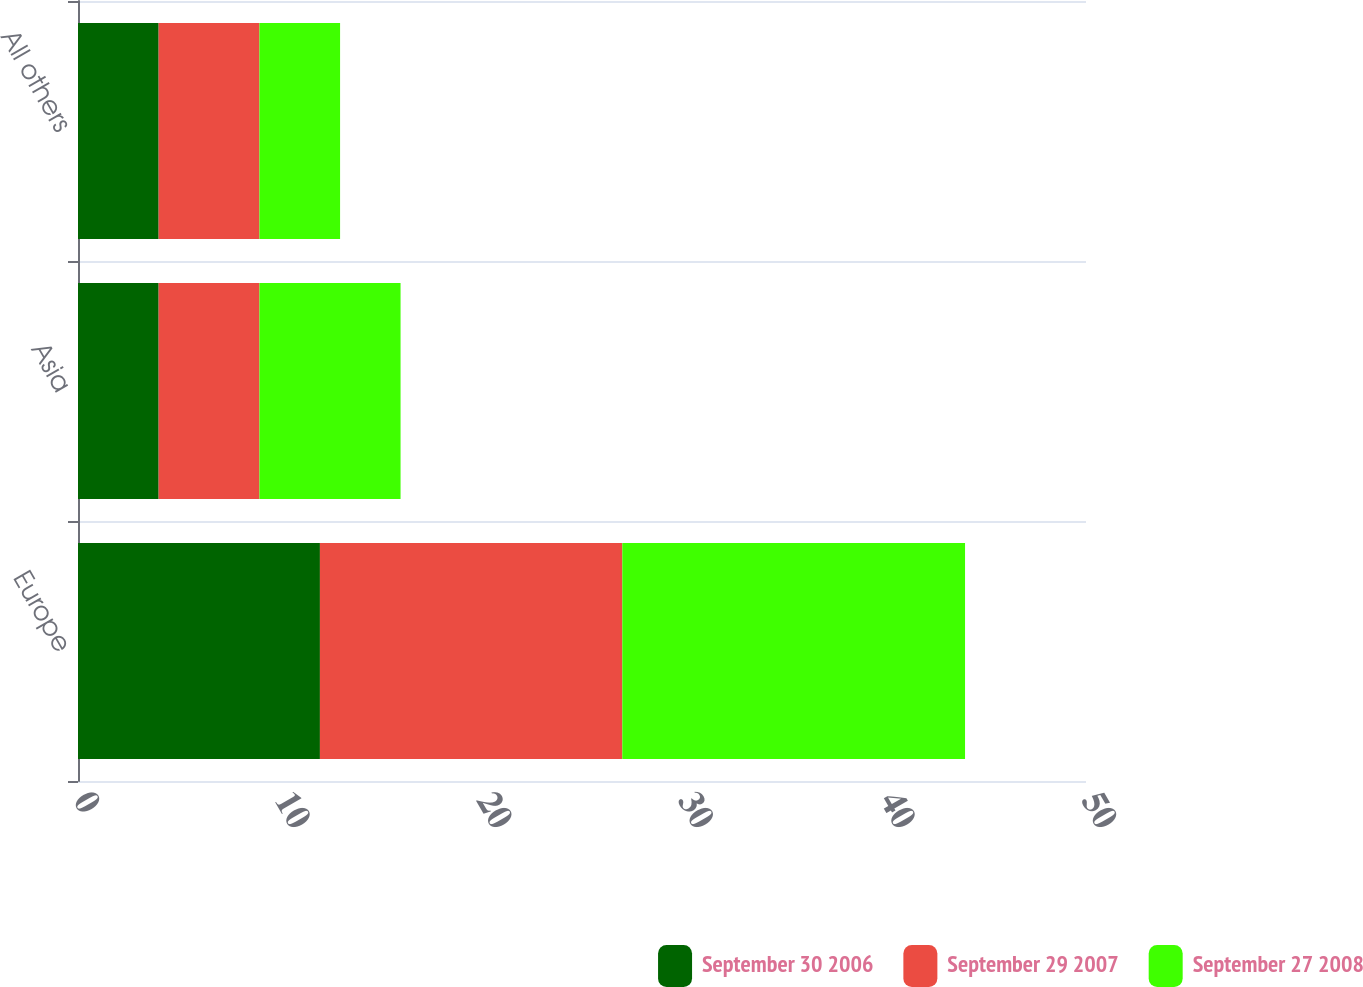Convert chart. <chart><loc_0><loc_0><loc_500><loc_500><stacked_bar_chart><ecel><fcel>Europe<fcel>Asia<fcel>All others<nl><fcel>September 30 2006<fcel>12<fcel>4<fcel>4<nl><fcel>September 29 2007<fcel>15<fcel>5<fcel>5<nl><fcel>September 27 2008<fcel>17<fcel>7<fcel>4<nl></chart> 